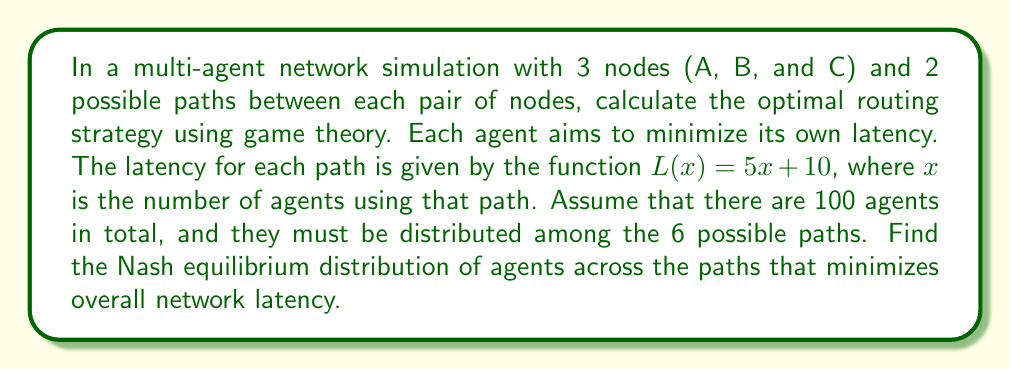Help me with this question. To solve this problem, we'll use the concept of Nash equilibrium from game theory. In a Nash equilibrium, no agent can unilaterally improve its situation by changing its strategy.

Step 1: Define the variables
Let $x_i$ be the number of agents using path $i$, where $i = 1, 2, ..., 6$

Step 2: Set up the constraints
$$\sum_{i=1}^6 x_i = 100$$
$$x_i \geq 0 \text{ for all } i$$

Step 3: Express the latency for each path
$L_i(x_i) = 5x_i + 10$ for $i = 1, 2, ..., 6$

Step 4: In Nash equilibrium, all used paths should have equal latency
If this weren't true, agents would switch to paths with lower latency.

Step 5: Solve the equilibrium equations
$5x_1 + 10 = 5x_2 + 10 = ... = 5x_6 + 10$
This implies $x_1 = x_2 = ... = x_6$

Step 6: Use the constraint to solve for $x_i$
$6x_i = 100$
$x_i = \frac{100}{6} \approx 16.67$

Step 7: Round to the nearest integer (since we can't have fractional agents)
$x_i = 17$ for $i = 1, 2, 3, 4, 5$
$x_6 = 15$ (to ensure the total is exactly 100)

Step 8: Calculate the equilibrium latency
$L = 5(17) + 10 = 95$ for the first 5 paths
$L = 5(15) + 10 = 85$ for the 6th path
Answer: The Nash equilibrium distribution is 17 agents on each of the first 5 paths and 15 agents on the 6th path. The equilibrium latency is 95 for the first 5 paths and 85 for the 6th path. 